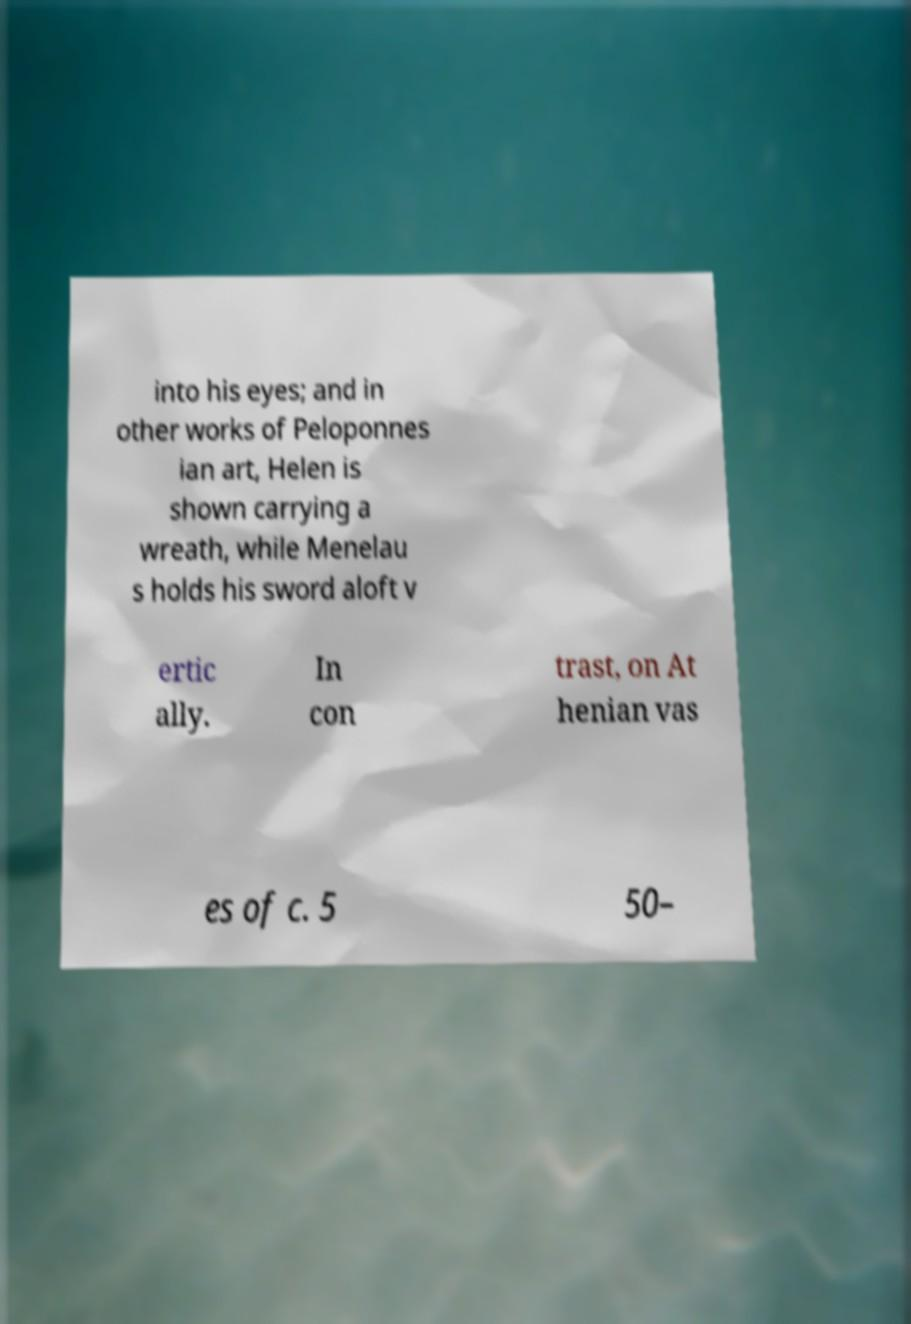Could you extract and type out the text from this image? into his eyes; and in other works of Peloponnes ian art, Helen is shown carrying a wreath, while Menelau s holds his sword aloft v ertic ally. In con trast, on At henian vas es of c. 5 50– 